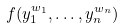<formula> <loc_0><loc_0><loc_500><loc_500>f ( y _ { 1 } ^ { w _ { 1 } } , \dots , y _ { n } ^ { w _ { n } } )</formula> 